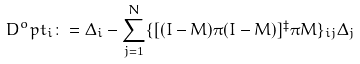<formula> <loc_0><loc_0><loc_500><loc_500>D ^ { o } p t _ { i } \colon = \Delta _ { i } - \sum _ { j = 1 } ^ { N } \{ [ ( I - M ) \pi ( I - M ) ] ^ { \ddagger } \pi M \} _ { i j } \Delta _ { j }</formula> 